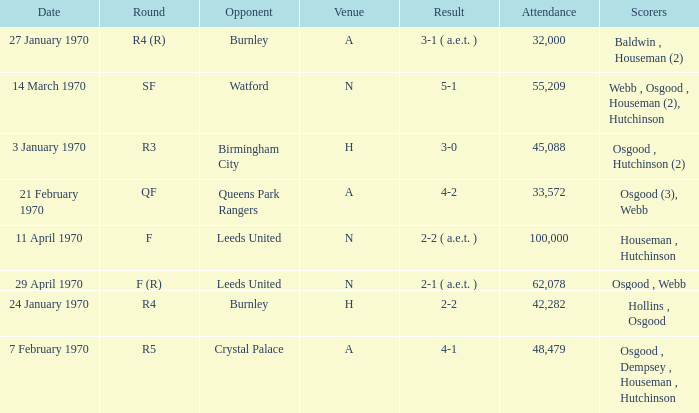What is the highest attendance at a game with a result of 5-1? 55209.0. Give me the full table as a dictionary. {'header': ['Date', 'Round', 'Opponent', 'Venue', 'Result', 'Attendance', 'Scorers'], 'rows': [['27 January 1970', 'R4 (R)', 'Burnley', 'A', '3-1 ( a.e.t. )', '32,000', 'Baldwin , Houseman (2)'], ['14 March 1970', 'SF', 'Watford', 'N', '5-1', '55,209', 'Webb , Osgood , Houseman (2), Hutchinson'], ['3 January 1970', 'R3', 'Birmingham City', 'H', '3-0', '45,088', 'Osgood , Hutchinson (2)'], ['21 February 1970', 'QF', 'Queens Park Rangers', 'A', '4-2', '33,572', 'Osgood (3), Webb'], ['11 April 1970', 'F', 'Leeds United', 'N', '2-2 ( a.e.t. )', '100,000', 'Houseman , Hutchinson'], ['29 April 1970', 'F (R)', 'Leeds United', 'N', '2-1 ( a.e.t. )', '62,078', 'Osgood , Webb'], ['24 January 1970', 'R4', 'Burnley', 'H', '2-2', '42,282', 'Hollins , Osgood'], ['7 February 1970', 'R5', 'Crystal Palace', 'A', '4-1', '48,479', 'Osgood , Dempsey , Houseman , Hutchinson']]} 